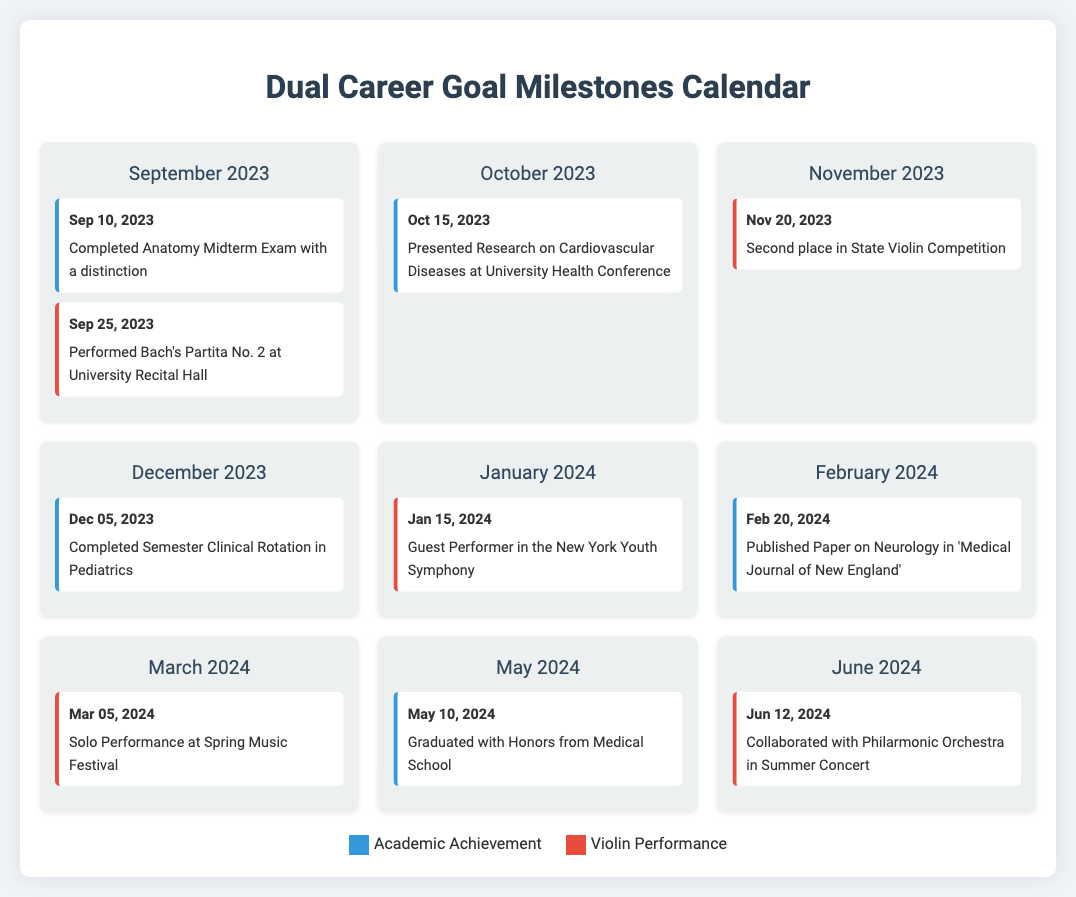what academic achievement was completed on Sep 10, 2023? The event on this date highlights an academic achievement, specifically the completion of the Anatomy Midterm Exam with a distinction.
Answer: Completed Anatomy Midterm Exam with a distinction when did the violinist perform Bach's Partita No. 2? This question focuses on a specific performance date listed under violin events in the calendar. The performance took place on Sep 25, 2023.
Answer: Sep 25, 2023 what milestone is noted for Nov 20, 2023? This refers to a violin performance event where the individual achieved a notable position in a competition.
Answer: Second place in State Violin Competition how long after the Anatomy Midterm Exam did the violinist perform at the recital? This question requires calculating the days between two events: the exam on Sep 10 and the performance on Sep 25.
Answer: 15 days how many academic events are listed in the calendar? The calendar details the events categorized under academic achievements, and counting them reveals a total of five events.
Answer: 5 what is the date of the solo performance at the Spring Music Festival? This question directly asks for the specific date of the violin performance event listed in March.
Answer: Mar 05, 2024 when was the paper on Neurology published? This question identifies the date when a significant academic achievement occurred, focusing on the publication details.
Answer: Feb 20, 2024 which event marks the end of the medical school journey in May 2024? The question seeks to clarify the culminating event related to academic achievements listed in the month of May.
Answer: Graduated with Honors from Medical School what is the significance of Jun 12, 2024, in the violinist's career? This date marks an important performance milestone in the musician's career, specifically a collaboration with an orchestra.
Answer: Collaborated with Philarmonic Orchestra in Summer Concert 